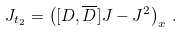Convert formula to latex. <formula><loc_0><loc_0><loc_500><loc_500>J _ { t _ { 2 } } = \left ( [ D , \overline { D } ] J - J ^ { 2 } \right ) _ { x } \, .</formula> 